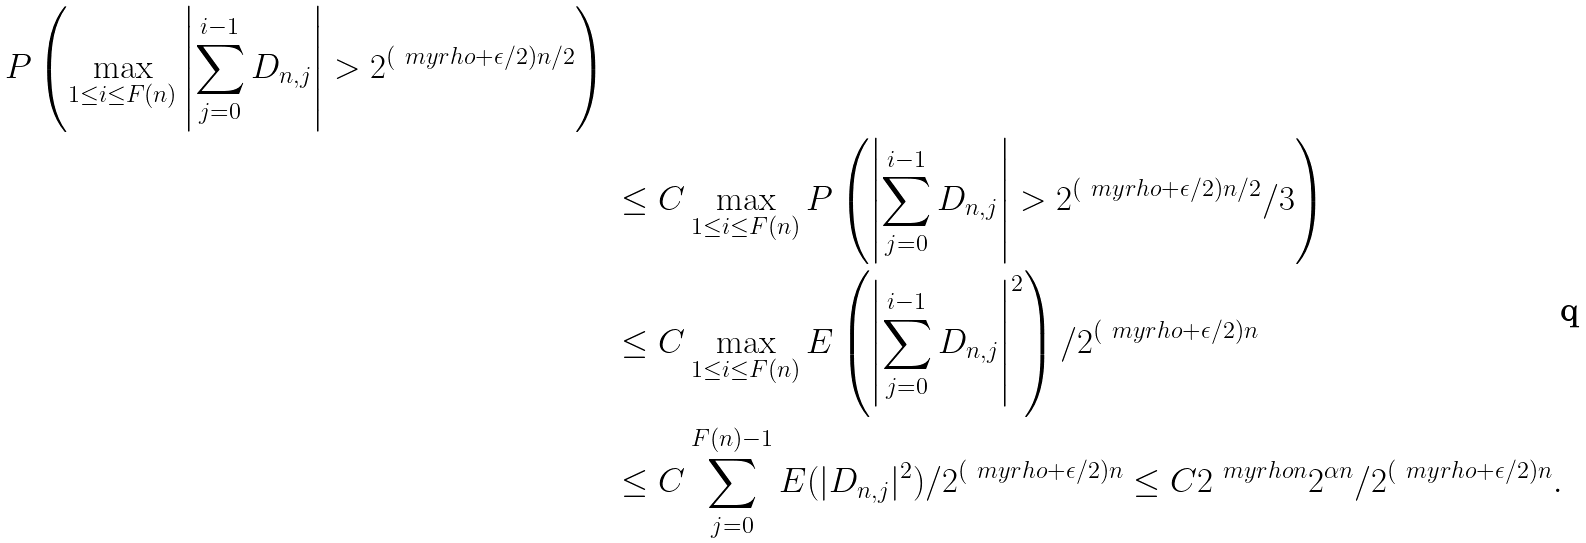<formula> <loc_0><loc_0><loc_500><loc_500>P \left ( \max _ { 1 \leq i \leq F ( n ) } \left | \sum _ { j = 0 } ^ { i - 1 } D _ { n , j } \right | > 2 ^ { ( \ m y r h o + \epsilon / 2 ) n / 2 } \right ) \, & \\ & \leq C \max _ { 1 \leq i \leq F ( n ) } P \left ( \left | \sum _ { j = 0 } ^ { i - 1 } D _ { n , j } \right | > 2 ^ { ( \ m y r h o + \epsilon / 2 ) n / 2 } / 3 \right ) \\ & \leq C \max _ { 1 \leq i \leq F ( n ) } E \left ( \left | \sum _ { j = 0 } ^ { i - 1 } D _ { n , j } \right | ^ { 2 } \right ) / 2 ^ { ( \ m y r h o + \epsilon / 2 ) n } \\ & \leq C \sum _ { j = 0 } ^ { F ( n ) - 1 } E ( | D _ { n , j } | ^ { 2 } ) / 2 ^ { ( \ m y r h o + \epsilon / 2 ) n } \leq C 2 ^ { \ m y r h o n } 2 ^ { \alpha n } / 2 ^ { ( \ m y r h o + \epsilon / 2 ) n } .</formula> 